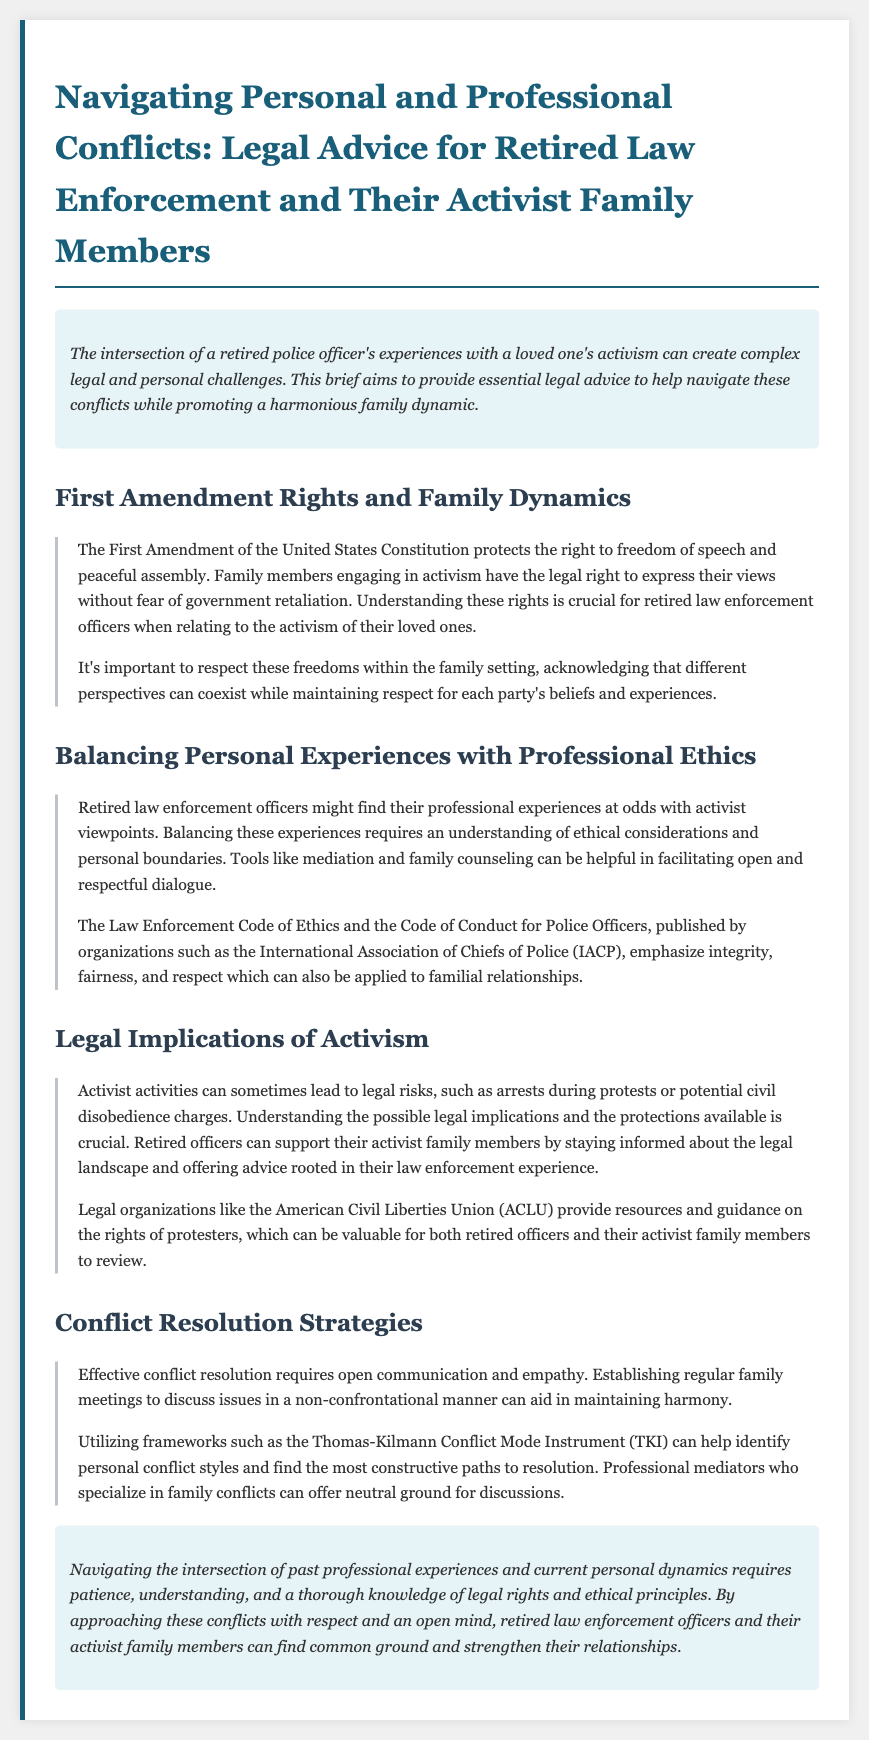what is the main focus of the legal brief? The main focus of the legal brief is to provide essential legal advice for navigating conflicts between retired law enforcement officers and their activist family members.
Answer: legal advice which constitutional right is discussed in relation to activism? The constitutional right discussed in relation to activism is the First Amendment, which protects freedom of speech and peaceful assembly.
Answer: First Amendment what tool is suggested for facilitating open dialogue in families? Mediation and family counseling are suggested tools for facilitating open dialogue.
Answer: mediation which organization is mentioned as a resource for legal guidance on protests? The American Civil Liberties Union (ACLU) is mentioned as a resource for legal guidance on protests.
Answer: ACLU what is emphasized in the Law Enforcement Code of Ethics? The Law Enforcement Code of Ethics emphasizes integrity, fairness, and respect.
Answer: integrity, fairness, respect how can families maintain harmony according to the document? Establishing regular family meetings to discuss issues can aid in maintaining harmony.
Answer: regular family meetings what conflict resolution framework is mentioned in the brief? The Thomas-Kilmann Conflict Mode Instrument (TKI) is mentioned as a conflict resolution framework.
Answer: TKI what is the conclusion's main message about navigating conflicts? The conclusion emphasizes the need for patience, understanding, and knowledge of legal rights and ethical principles when navigating conflicts.
Answer: patience, understanding, knowledge 